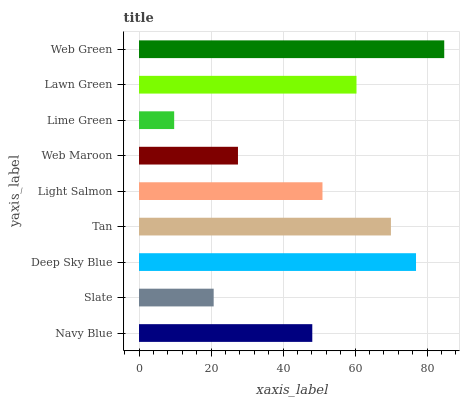Is Lime Green the minimum?
Answer yes or no. Yes. Is Web Green the maximum?
Answer yes or no. Yes. Is Slate the minimum?
Answer yes or no. No. Is Slate the maximum?
Answer yes or no. No. Is Navy Blue greater than Slate?
Answer yes or no. Yes. Is Slate less than Navy Blue?
Answer yes or no. Yes. Is Slate greater than Navy Blue?
Answer yes or no. No. Is Navy Blue less than Slate?
Answer yes or no. No. Is Light Salmon the high median?
Answer yes or no. Yes. Is Light Salmon the low median?
Answer yes or no. Yes. Is Tan the high median?
Answer yes or no. No. Is Web Green the low median?
Answer yes or no. No. 